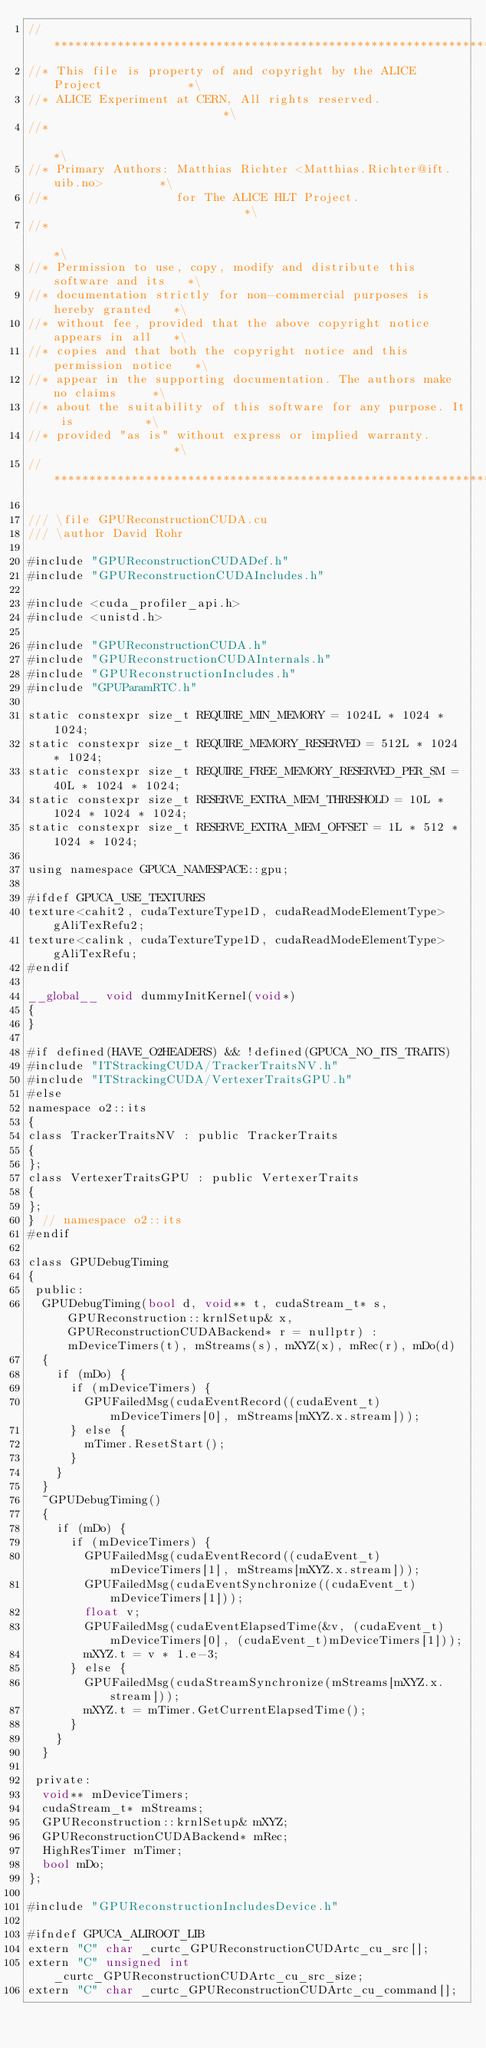<code> <loc_0><loc_0><loc_500><loc_500><_Cuda_>//**************************************************************************\
//* This file is property of and copyright by the ALICE Project            *\
//* ALICE Experiment at CERN, All rights reserved.                         *\
//*                                                                        *\
//* Primary Authors: Matthias Richter <Matthias.Richter@ift.uib.no>        *\
//*                  for The ALICE HLT Project.                            *\
//*                                                                        *\
//* Permission to use, copy, modify and distribute this software and its   *\
//* documentation strictly for non-commercial purposes is hereby granted   *\
//* without fee, provided that the above copyright notice appears in all   *\
//* copies and that both the copyright notice and this permission notice   *\
//* appear in the supporting documentation. The authors make no claims     *\
//* about the suitability of this software for any purpose. It is          *\
//* provided "as is" without express or implied warranty.                  *\
//**************************************************************************

/// \file GPUReconstructionCUDA.cu
/// \author David Rohr

#include "GPUReconstructionCUDADef.h"
#include "GPUReconstructionCUDAIncludes.h"

#include <cuda_profiler_api.h>
#include <unistd.h>

#include "GPUReconstructionCUDA.h"
#include "GPUReconstructionCUDAInternals.h"
#include "GPUReconstructionIncludes.h"
#include "GPUParamRTC.h"

static constexpr size_t REQUIRE_MIN_MEMORY = 1024L * 1024 * 1024;
static constexpr size_t REQUIRE_MEMORY_RESERVED = 512L * 1024 * 1024;
static constexpr size_t REQUIRE_FREE_MEMORY_RESERVED_PER_SM = 40L * 1024 * 1024;
static constexpr size_t RESERVE_EXTRA_MEM_THRESHOLD = 10L * 1024 * 1024 * 1024;
static constexpr size_t RESERVE_EXTRA_MEM_OFFSET = 1L * 512 * 1024 * 1024;

using namespace GPUCA_NAMESPACE::gpu;

#ifdef GPUCA_USE_TEXTURES
texture<cahit2, cudaTextureType1D, cudaReadModeElementType> gAliTexRefu2;
texture<calink, cudaTextureType1D, cudaReadModeElementType> gAliTexRefu;
#endif

__global__ void dummyInitKernel(void*)
{
}

#if defined(HAVE_O2HEADERS) && !defined(GPUCA_NO_ITS_TRAITS)
#include "ITStrackingCUDA/TrackerTraitsNV.h"
#include "ITStrackingCUDA/VertexerTraitsGPU.h"
#else
namespace o2::its
{
class TrackerTraitsNV : public TrackerTraits
{
};
class VertexerTraitsGPU : public VertexerTraits
{
};
} // namespace o2::its
#endif

class GPUDebugTiming
{
 public:
  GPUDebugTiming(bool d, void** t, cudaStream_t* s, GPUReconstruction::krnlSetup& x, GPUReconstructionCUDABackend* r = nullptr) : mDeviceTimers(t), mStreams(s), mXYZ(x), mRec(r), mDo(d)
  {
    if (mDo) {
      if (mDeviceTimers) {
        GPUFailedMsg(cudaEventRecord((cudaEvent_t)mDeviceTimers[0], mStreams[mXYZ.x.stream]));
      } else {
        mTimer.ResetStart();
      }
    }
  }
  ~GPUDebugTiming()
  {
    if (mDo) {
      if (mDeviceTimers) {
        GPUFailedMsg(cudaEventRecord((cudaEvent_t)mDeviceTimers[1], mStreams[mXYZ.x.stream]));
        GPUFailedMsg(cudaEventSynchronize((cudaEvent_t)mDeviceTimers[1]));
        float v;
        GPUFailedMsg(cudaEventElapsedTime(&v, (cudaEvent_t)mDeviceTimers[0], (cudaEvent_t)mDeviceTimers[1]));
        mXYZ.t = v * 1.e-3;
      } else {
        GPUFailedMsg(cudaStreamSynchronize(mStreams[mXYZ.x.stream]));
        mXYZ.t = mTimer.GetCurrentElapsedTime();
      }
    }
  }

 private:
  void** mDeviceTimers;
  cudaStream_t* mStreams;
  GPUReconstruction::krnlSetup& mXYZ;
  GPUReconstructionCUDABackend* mRec;
  HighResTimer mTimer;
  bool mDo;
};

#include "GPUReconstructionIncludesDevice.h"

#ifndef GPUCA_ALIROOT_LIB
extern "C" char _curtc_GPUReconstructionCUDArtc_cu_src[];
extern "C" unsigned int _curtc_GPUReconstructionCUDArtc_cu_src_size;
extern "C" char _curtc_GPUReconstructionCUDArtc_cu_command[];</code> 